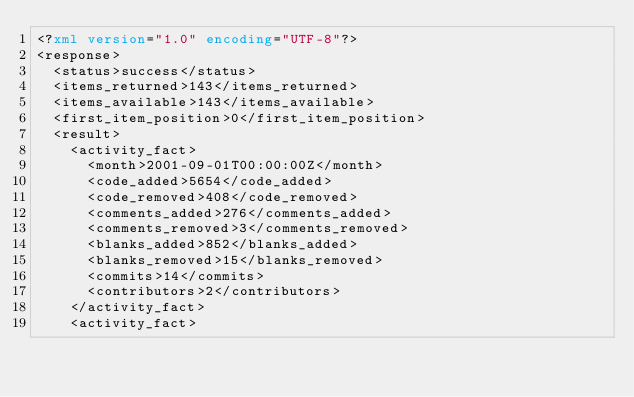<code> <loc_0><loc_0><loc_500><loc_500><_XML_><?xml version="1.0" encoding="UTF-8"?>
<response>
  <status>success</status>
  <items_returned>143</items_returned>
  <items_available>143</items_available>
  <first_item_position>0</first_item_position>
  <result>
    <activity_fact>
      <month>2001-09-01T00:00:00Z</month>
      <code_added>5654</code_added>
      <code_removed>408</code_removed>
      <comments_added>276</comments_added>
      <comments_removed>3</comments_removed>
      <blanks_added>852</blanks_added>
      <blanks_removed>15</blanks_removed>
      <commits>14</commits>
      <contributors>2</contributors>
    </activity_fact>
    <activity_fact></code> 